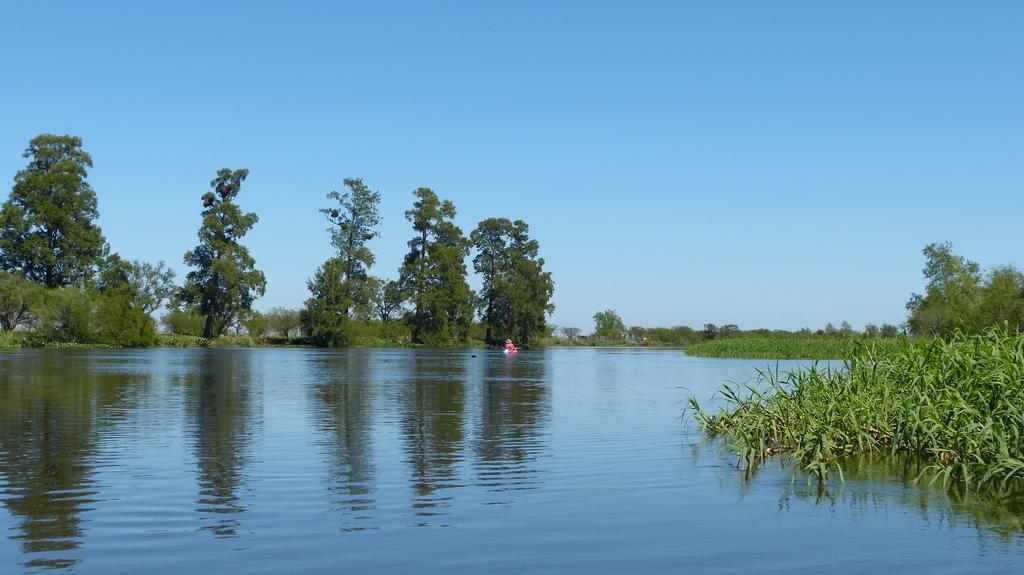Describe this image in one or two sentences. In the background we can see the sky. In this picture we can see the trees, plants and water. We can see pink color object. 